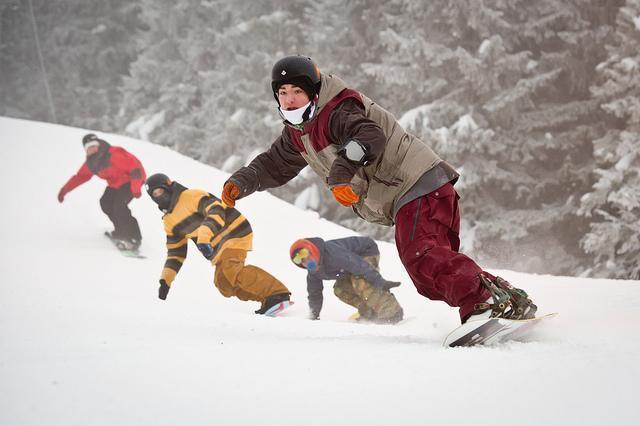Why are the men leaning to one side?
Indicate the correct response by choosing from the four available options to answer the question.
Options: To turn, to dance, to exercise, to wrestle. To turn. 